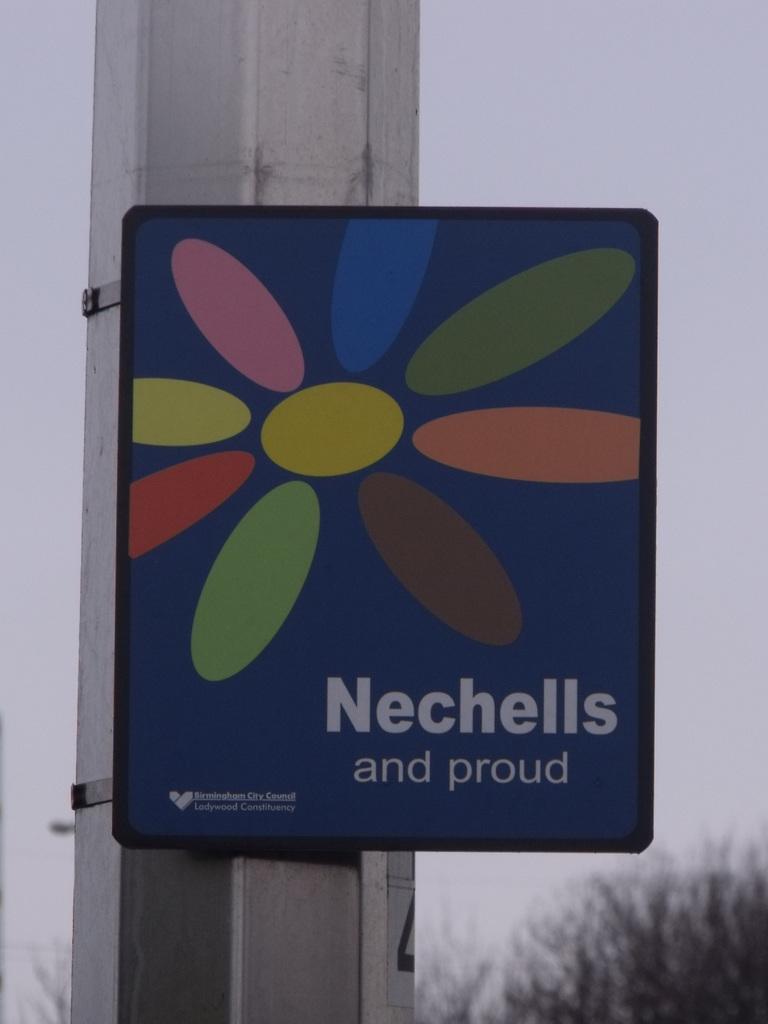What is the name on the board?
Keep it short and to the point. Nechells. 